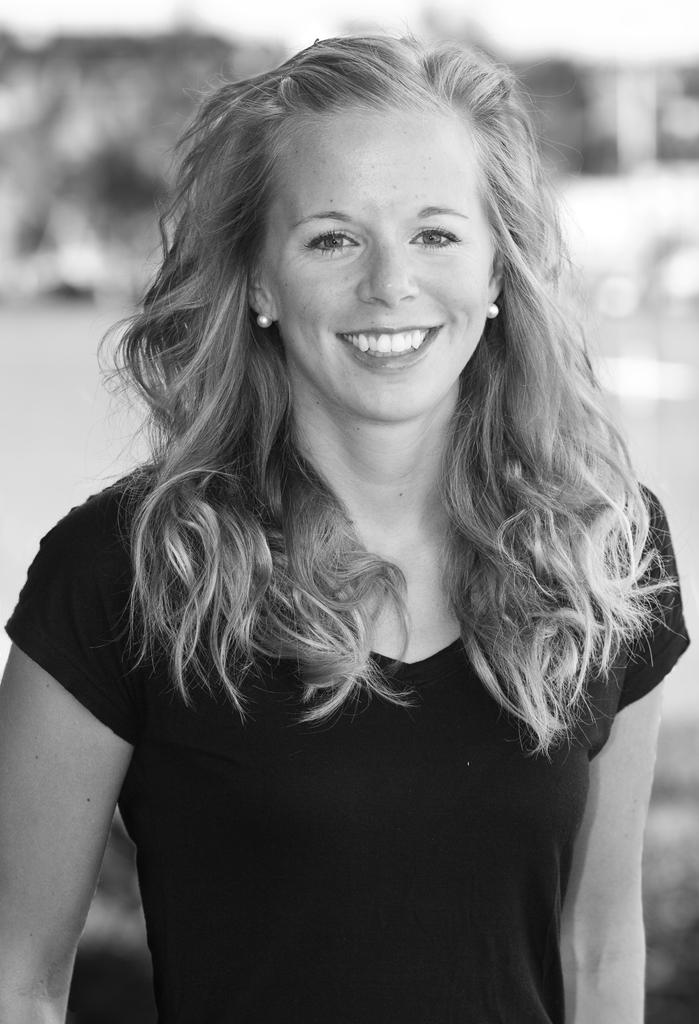What is the main subject of the image? The main subject of the image is a woman. What is the woman doing in the image? The woman is standing in the middle of the image and smiling. Can you describe the background of the image? The background of the image is blurred. What type of reward is the woman holding in the image? There is no reward visible in the image; the woman is simply standing and smiling. 